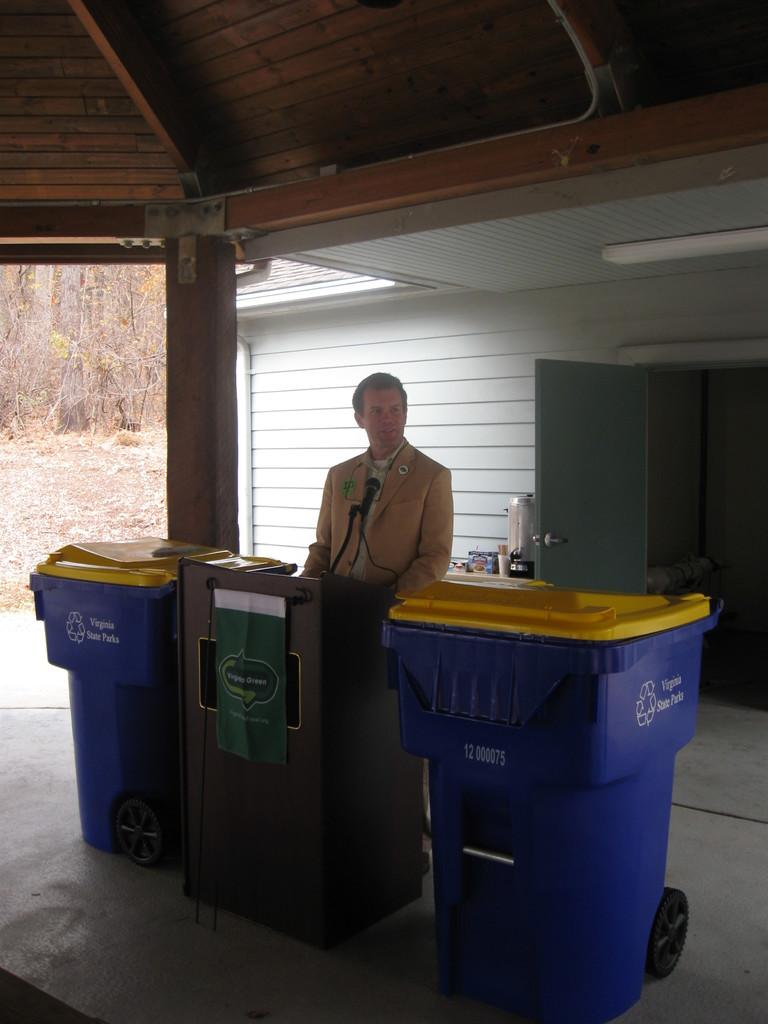<image>
Create a compact narrative representing the image presented. Man standing next to some blue garbage bins that say "Virginia State Parks". 